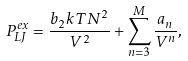<formula> <loc_0><loc_0><loc_500><loc_500>P ^ { e x } _ { L J } = \frac { b _ { 2 } k T N ^ { 2 } } { V ^ { 2 } } + \sum _ { n = 3 } ^ { M } \frac { a _ { n } } { V ^ { n } } ,</formula> 